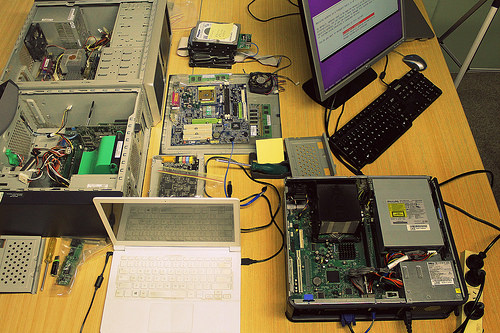<image>
Is there a screen above the computer? No. The screen is not positioned above the computer. The vertical arrangement shows a different relationship. 